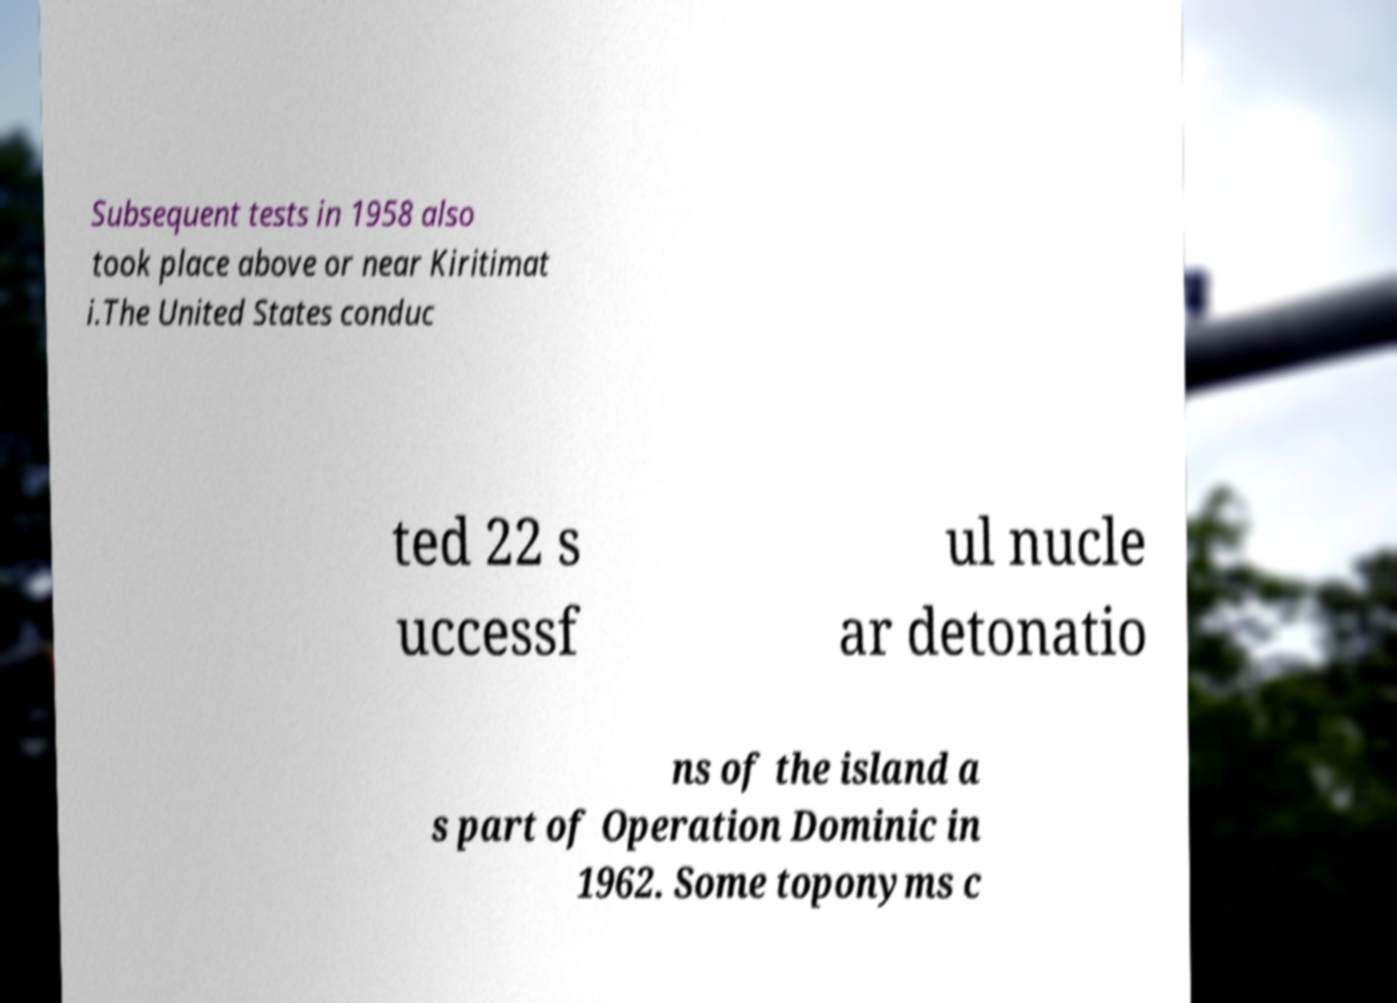Can you read and provide the text displayed in the image?This photo seems to have some interesting text. Can you extract and type it out for me? Subsequent tests in 1958 also took place above or near Kiritimat i.The United States conduc ted 22 s uccessf ul nucle ar detonatio ns of the island a s part of Operation Dominic in 1962. Some toponyms c 